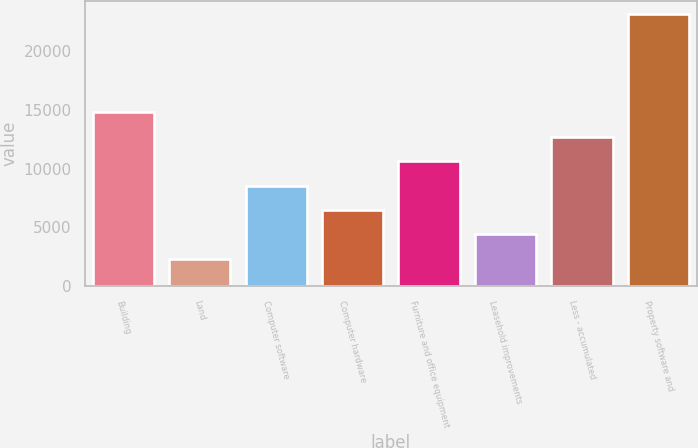<chart> <loc_0><loc_0><loc_500><loc_500><bar_chart><fcel>Building<fcel>Land<fcel>Computer software<fcel>Computer hardware<fcel>Furniture and office equipment<fcel>Leasehold improvements<fcel>Less - accumulated<fcel>Property software and<nl><fcel>14791.6<fcel>2320<fcel>8555.8<fcel>6477.2<fcel>10634.4<fcel>4398.6<fcel>12713<fcel>23106<nl></chart> 